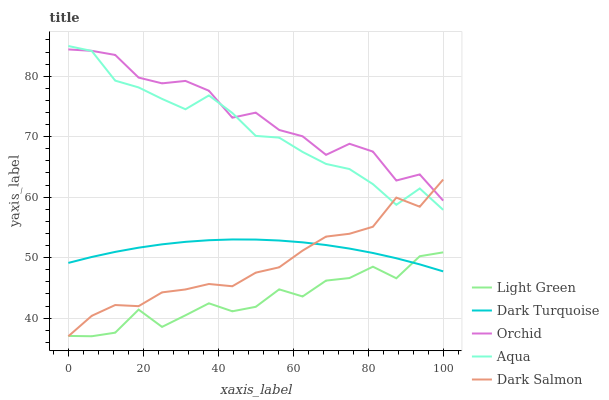Does Light Green have the minimum area under the curve?
Answer yes or no. Yes. Does Orchid have the maximum area under the curve?
Answer yes or no. Yes. Does Aqua have the minimum area under the curve?
Answer yes or no. No. Does Aqua have the maximum area under the curve?
Answer yes or no. No. Is Dark Turquoise the smoothest?
Answer yes or no. Yes. Is Orchid the roughest?
Answer yes or no. Yes. Is Aqua the smoothest?
Answer yes or no. No. Is Aqua the roughest?
Answer yes or no. No. Does Dark Salmon have the lowest value?
Answer yes or no. Yes. Does Aqua have the lowest value?
Answer yes or no. No. Does Aqua have the highest value?
Answer yes or no. Yes. Does Dark Salmon have the highest value?
Answer yes or no. No. Is Light Green less than Orchid?
Answer yes or no. Yes. Is Orchid greater than Dark Turquoise?
Answer yes or no. Yes. Does Dark Salmon intersect Orchid?
Answer yes or no. Yes. Is Dark Salmon less than Orchid?
Answer yes or no. No. Is Dark Salmon greater than Orchid?
Answer yes or no. No. Does Light Green intersect Orchid?
Answer yes or no. No. 